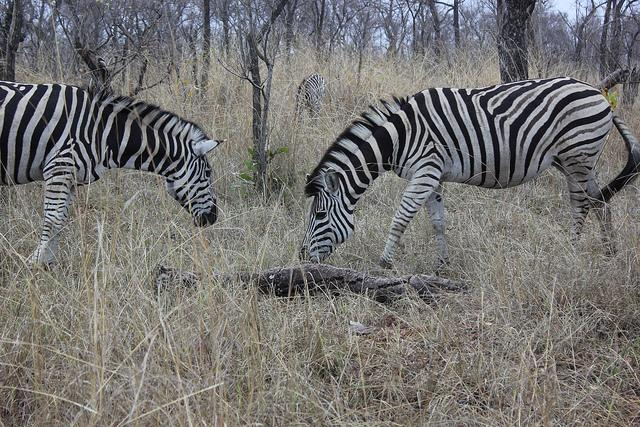What matches the color scheme of the animals? Please explain your reasoning. piano keys. The colors are like keys. 